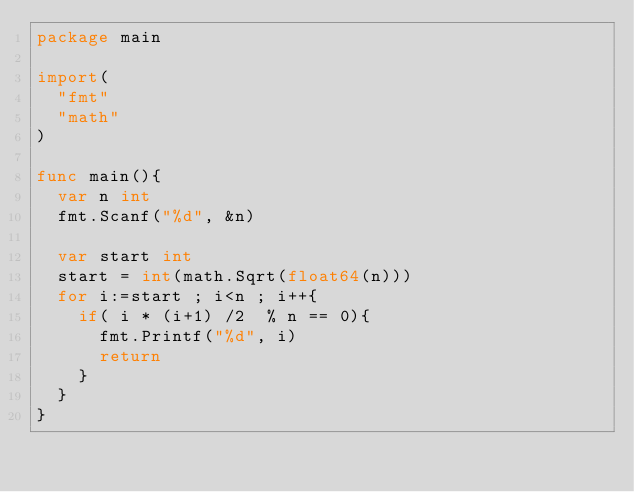Convert code to text. <code><loc_0><loc_0><loc_500><loc_500><_Go_>package main

import(
  "fmt"
  "math"
)

func main(){
  var n int
  fmt.Scanf("%d", &n)
  
  var start int
  start = int(math.Sqrt(float64(n)))
  for i:=start ; i<n ; i++{
    if( i * (i+1) /2  % n == 0){
      fmt.Printf("%d", i)
      return
  	}
  }
}</code> 